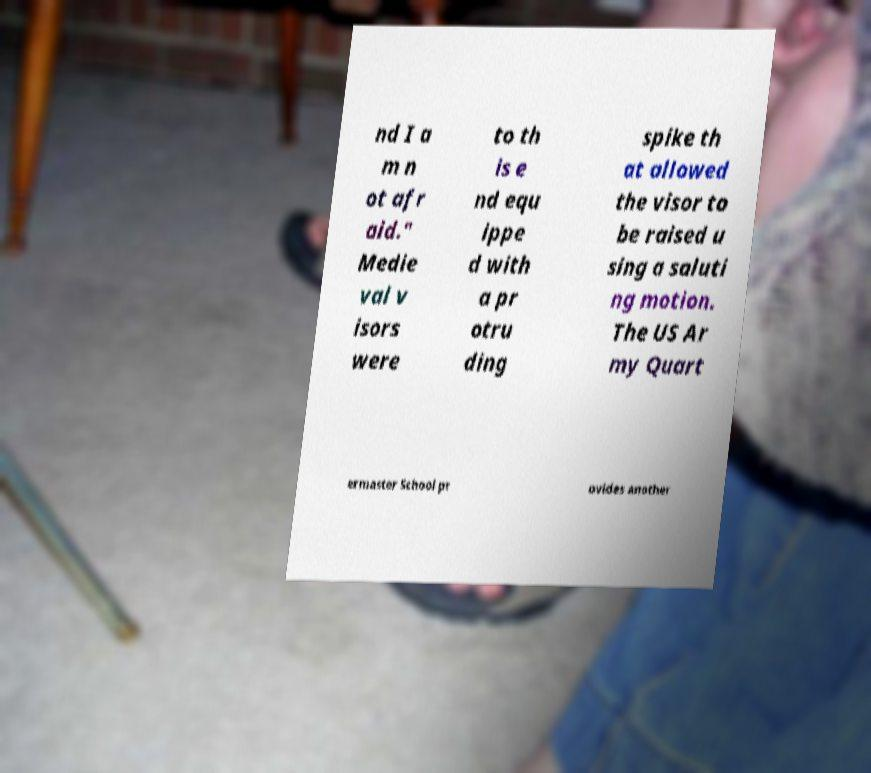Please read and relay the text visible in this image. What does it say? nd I a m n ot afr aid." Medie val v isors were to th is e nd equ ippe d with a pr otru ding spike th at allowed the visor to be raised u sing a saluti ng motion. The US Ar my Quart ermaster School pr ovides another 